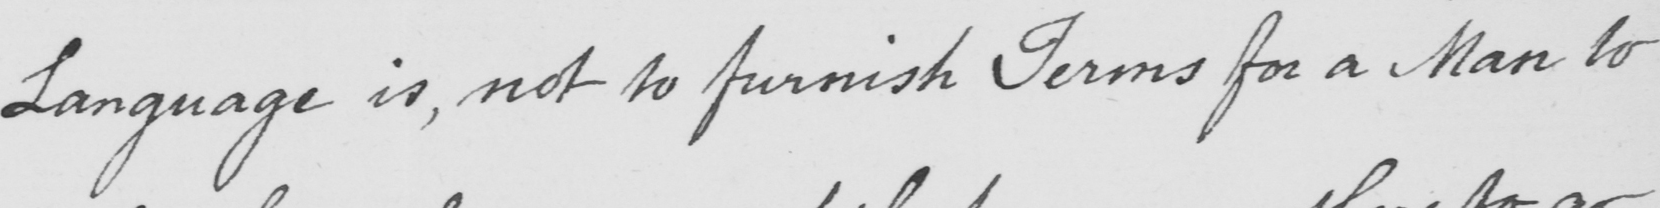What is written in this line of handwriting? Language is , not to furnish Terms for a Man to 